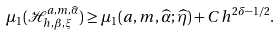Convert formula to latex. <formula><loc_0><loc_0><loc_500><loc_500>\mu _ { 1 } ( \mathcal { H } _ { h , \beta , \xi } ^ { a , m , \widehat { \alpha } } ) \geq \mu _ { 1 } ( a , m , \widehat { \alpha } ; \widehat { \eta } ) + C h ^ { 2 \delta - 1 / 2 } .</formula> 